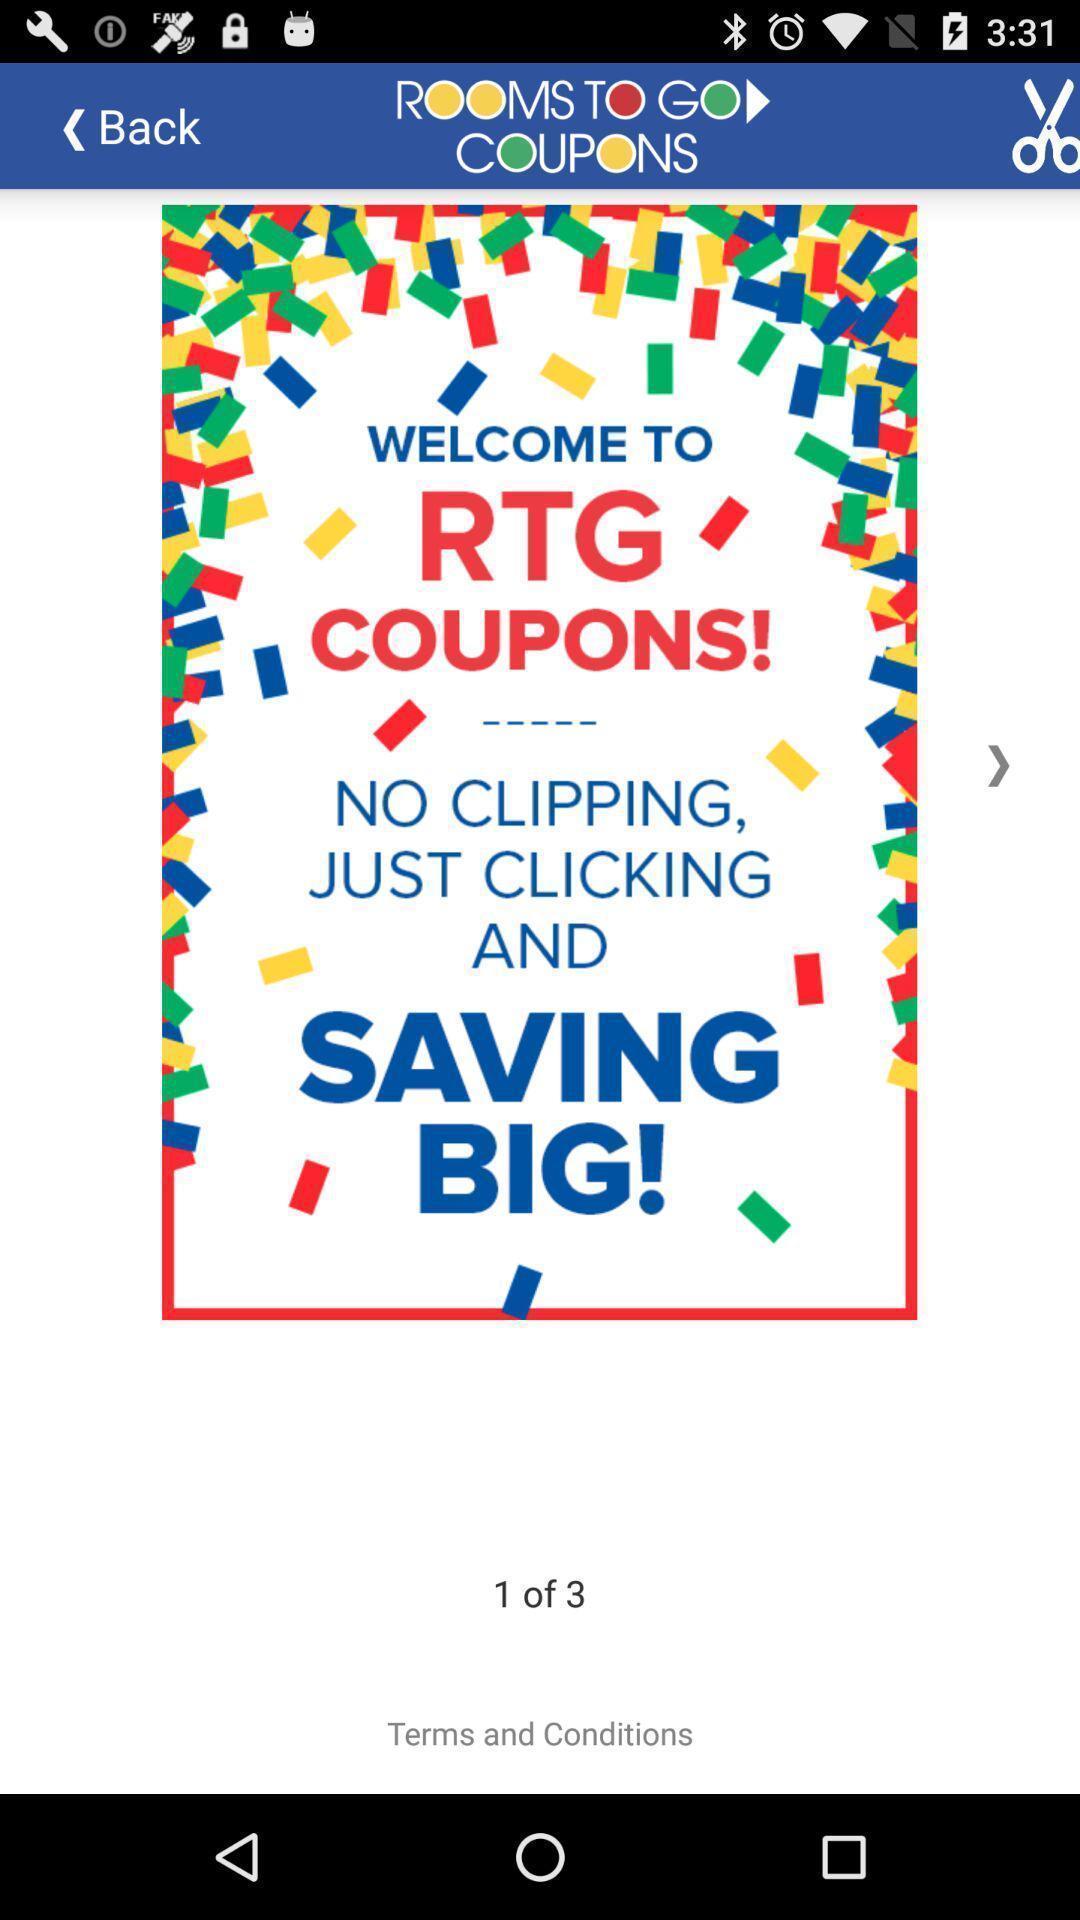What can you discern from this picture? Welcome page of social app. 